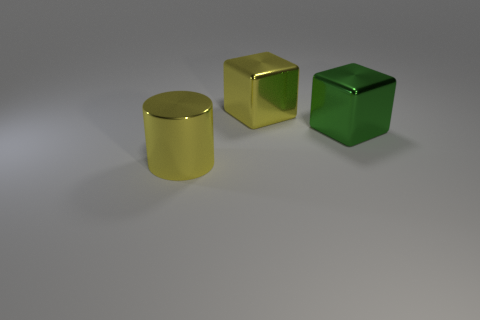How do the textures of the objects compare to each other? The objects in the image all exhibit smooth, reflective surfaces indicitave of polished metal. However, light interacts with each object's surface distinctly, slightly altering the perception of their textures. Do the shadows provide any information about the light source? Yes, the shadows cast by the objects suggest a light source located above and slightly to the right of the scene, as evidenced by the direction and length of the shadows. 